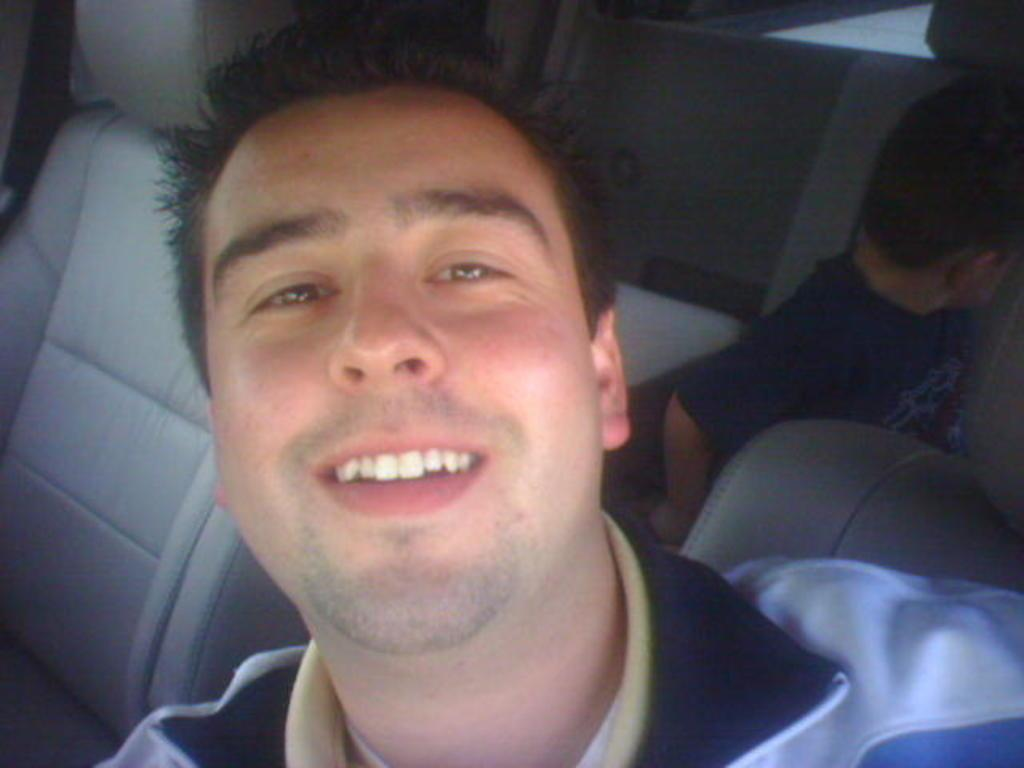Who is present in the image? There is a man and a kid in the image. What are the man and the kid doing in the image? Both the man and the kid are in a vehicle. What type of legal advice is the lawyer providing to the man and the kid in the image? There is no lawyer present in the image, and therefore no legal advice is being provided. 